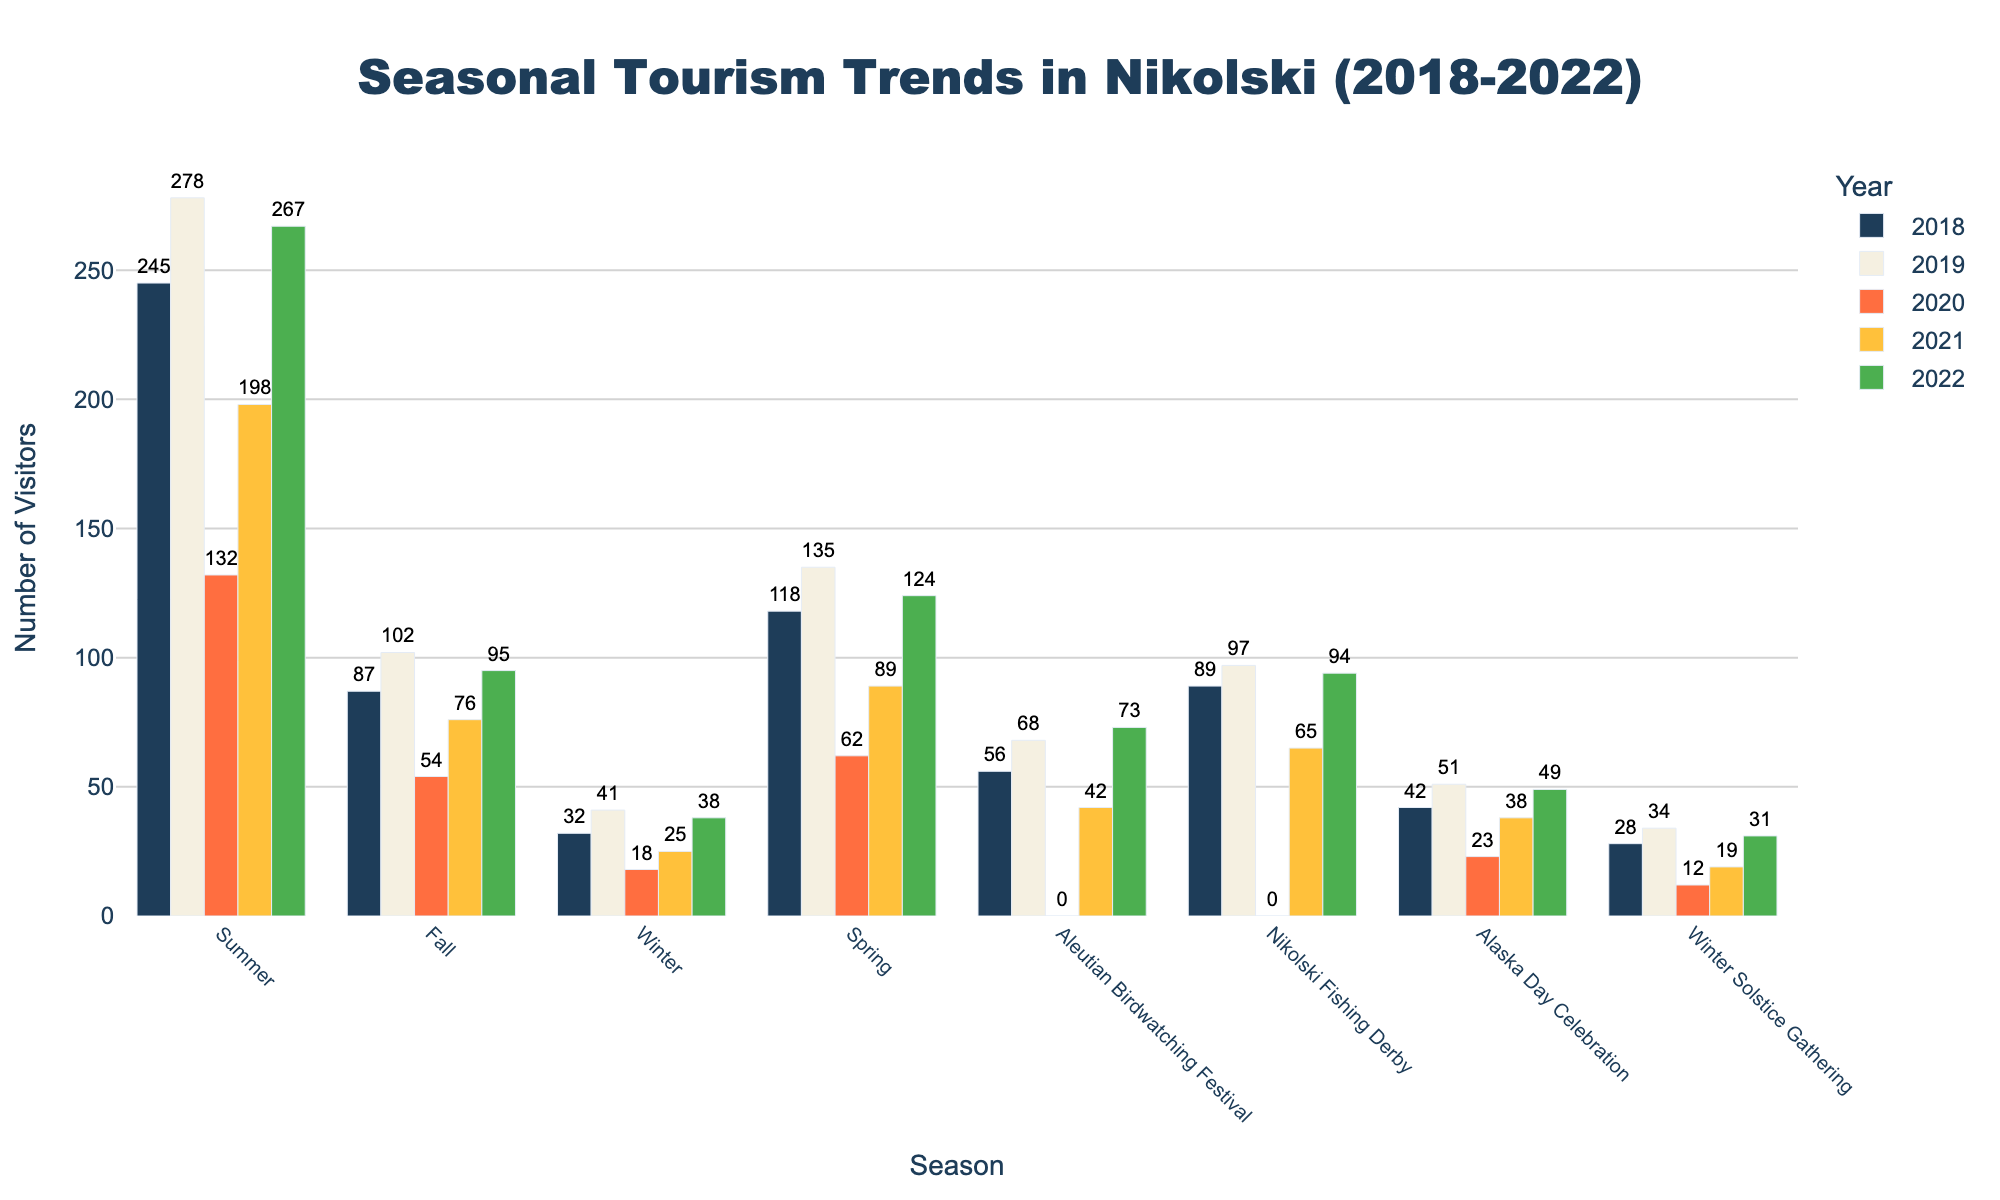What's the total number of visitors in Summer and Fall of 2022? The number of visitors in Summer of 2022 is 267 and in Fall of 2022 is 95. Adding these together, 267 + 95 = 362
Answer: 362 Which year had the highest number of visitors during the Winter Solstice Gathering? Looking at each bar in the Winter Solstice Gathering group, the year 2022 has the highest bar with 31 visitors
Answer: 2022 Which season experienced the largest drop in visitors from 2019 to 2020? Comparing the heights of the bars from 2019 to 2020 for each season, Spring shows the largest drop: 135 (2019) - 62 (2020) = 73
Answer: Spring In which year did the Aleutian Birdwatching Festival have no visitors? Observing the bars for the Aleutian Birdwatching Festival, only the year 2020 has no bar, meaning 0 visitors
Answer: 2020 What's the average number of visitors to the Alaska Day Celebration over the 5 years? The numbers are 42, 51, 23, 38, and 49. Adding them together is 42 + 51 + 23 + 38 + 49 = 203. Dividing by 5, the average is 203 / 5 = 40.6
Answer: 40.6 Which season had more visitors in 2021: Spring or Fall? In 2021 the visitors for Spring are 89 and for Fall are 76. Comparing these, Spring had more visitors
Answer: Spring For which event do the years 2018 and 2022 have the closest number of visitors? By comparing the bars for 2018 and 2022 in all events, the Nikolski Fishing Derby has the closest: 2018 (89) and 2022 (94), difference is 5
Answer: Nikolski Fishing Derby How many more visitors did Summer have in 2022 compared to 2021? The number of visitors in Summer for 2022 is 267 and for 2021 is 198. Subtracting these, 267 - 198 = 69
Answer: 69 What's the difference between the maximum number of visitors in any season and the minimum number of visitors in any event over the 5 years? The maximum number of visitors in any season is Summer 2019 with 278. The minimum number of visitors in any event is the Winter Solstice Gathering 2020 with 12. The difference is 278 - 12 = 266
Answer: 266 Which event saw the biggest increase in visitors from 2021 to 2022? By comparing the change in the heights of the bars from 2021 to 2022 for all events, the Aleutian Birdwatching Festival increased from 42 to 73, a difference of 31 visitors, the biggest increase
Answer: Aleutian Birdwatching Festival 